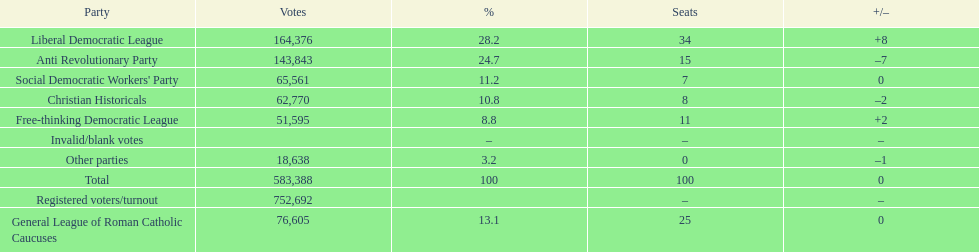Name the top three parties? Liberal Democratic League, Anti Revolutionary Party, General League of Roman Catholic Caucuses. 